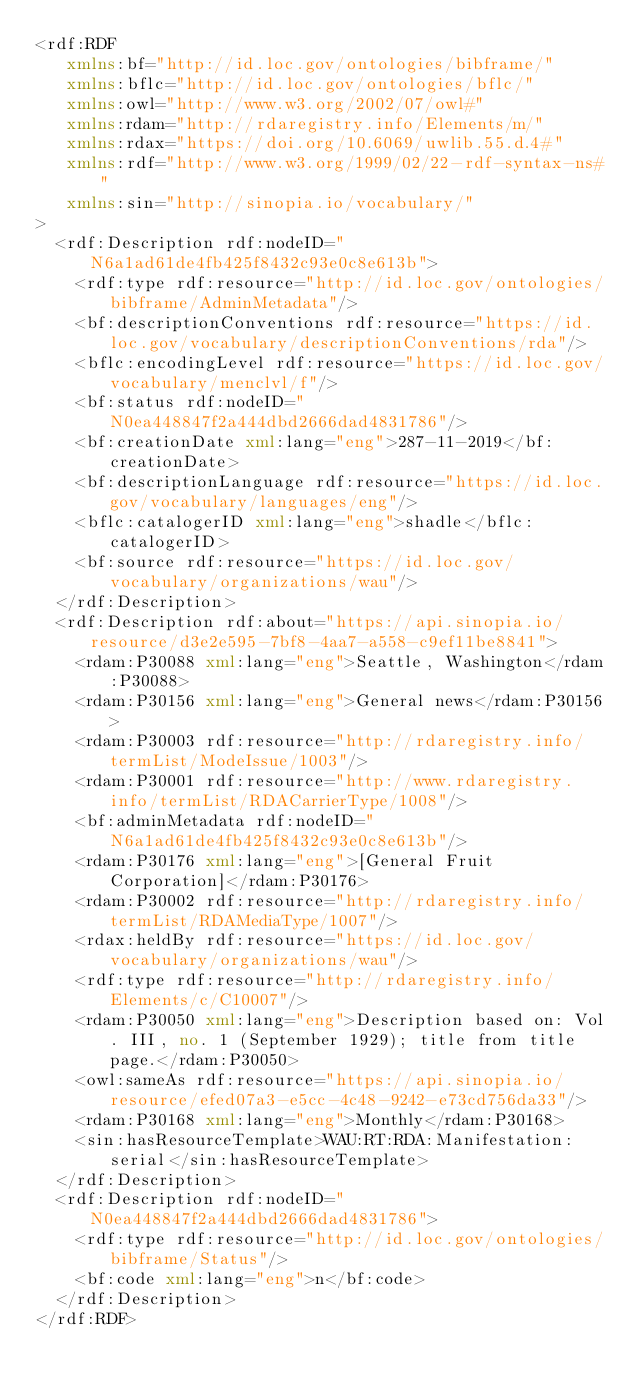<code> <loc_0><loc_0><loc_500><loc_500><_XML_><rdf:RDF
   xmlns:bf="http://id.loc.gov/ontologies/bibframe/"
   xmlns:bflc="http://id.loc.gov/ontologies/bflc/"
   xmlns:owl="http://www.w3.org/2002/07/owl#"
   xmlns:rdam="http://rdaregistry.info/Elements/m/"
   xmlns:rdax="https://doi.org/10.6069/uwlib.55.d.4#"
   xmlns:rdf="http://www.w3.org/1999/02/22-rdf-syntax-ns#"
   xmlns:sin="http://sinopia.io/vocabulary/"
>
  <rdf:Description rdf:nodeID="N6a1ad61de4fb425f8432c93e0c8e613b">
    <rdf:type rdf:resource="http://id.loc.gov/ontologies/bibframe/AdminMetadata"/>
    <bf:descriptionConventions rdf:resource="https://id.loc.gov/vocabulary/descriptionConventions/rda"/>
    <bflc:encodingLevel rdf:resource="https://id.loc.gov/vocabulary/menclvl/f"/>
    <bf:status rdf:nodeID="N0ea448847f2a444dbd2666dad4831786"/>
    <bf:creationDate xml:lang="eng">287-11-2019</bf:creationDate>
    <bf:descriptionLanguage rdf:resource="https://id.loc.gov/vocabulary/languages/eng"/>
    <bflc:catalogerID xml:lang="eng">shadle</bflc:catalogerID>
    <bf:source rdf:resource="https://id.loc.gov/vocabulary/organizations/wau"/>
  </rdf:Description>
  <rdf:Description rdf:about="https://api.sinopia.io/resource/d3e2e595-7bf8-4aa7-a558-c9ef11be8841">
    <rdam:P30088 xml:lang="eng">Seattle, Washington</rdam:P30088>
    <rdam:P30156 xml:lang="eng">General news</rdam:P30156>
    <rdam:P30003 rdf:resource="http://rdaregistry.info/termList/ModeIssue/1003"/>
    <rdam:P30001 rdf:resource="http://www.rdaregistry.info/termList/RDACarrierType/1008"/>
    <bf:adminMetadata rdf:nodeID="N6a1ad61de4fb425f8432c93e0c8e613b"/>
    <rdam:P30176 xml:lang="eng">[General Fruit Corporation]</rdam:P30176>
    <rdam:P30002 rdf:resource="http://rdaregistry.info/termList/RDAMediaType/1007"/>
    <rdax:heldBy rdf:resource="https://id.loc.gov/vocabulary/organizations/wau"/>
    <rdf:type rdf:resource="http://rdaregistry.info/Elements/c/C10007"/>
    <rdam:P30050 xml:lang="eng">Description based on: Vol. III, no. 1 (September 1929); title from title page.</rdam:P30050>
    <owl:sameAs rdf:resource="https://api.sinopia.io/resource/efed07a3-e5cc-4c48-9242-e73cd756da33"/>
    <rdam:P30168 xml:lang="eng">Monthly</rdam:P30168>
    <sin:hasResourceTemplate>WAU:RT:RDA:Manifestation:serial</sin:hasResourceTemplate>
  </rdf:Description>
  <rdf:Description rdf:nodeID="N0ea448847f2a444dbd2666dad4831786">
    <rdf:type rdf:resource="http://id.loc.gov/ontologies/bibframe/Status"/>
    <bf:code xml:lang="eng">n</bf:code>
  </rdf:Description>
</rdf:RDF>
</code> 